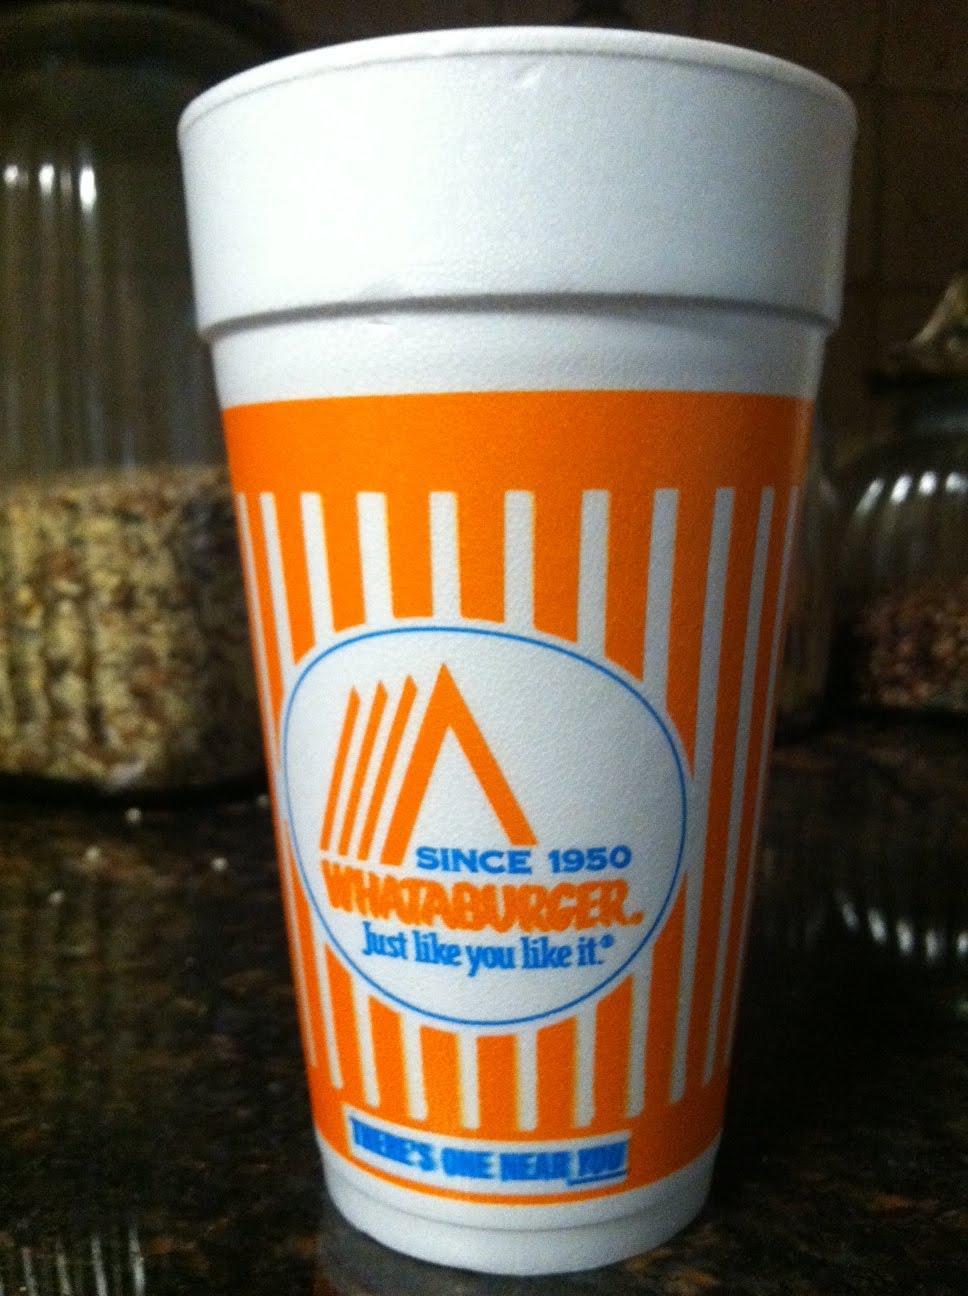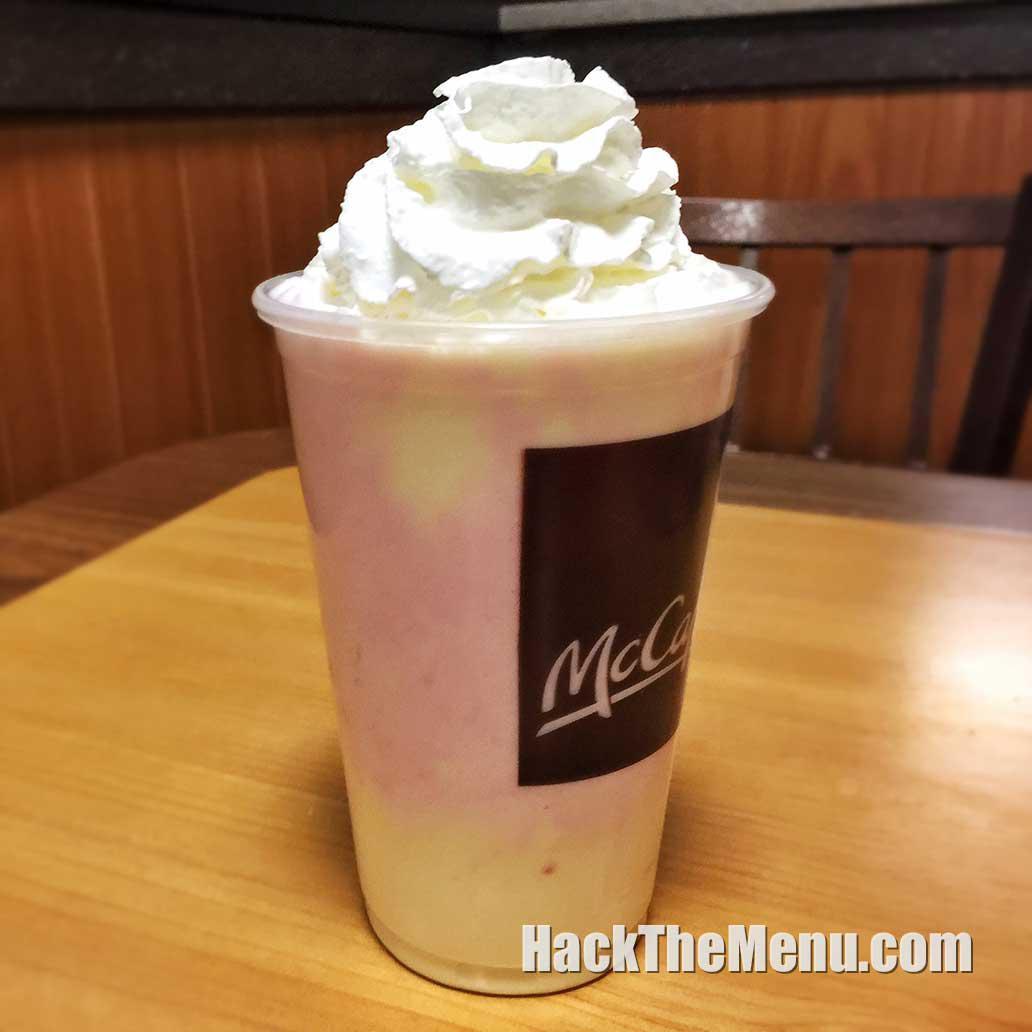The first image is the image on the left, the second image is the image on the right. Analyze the images presented: Is the assertion "The right image shows a """"Whataburger"""" cup sitting on a surface." valid? Answer yes or no. No. The first image is the image on the left, the second image is the image on the right. Analyze the images presented: Is the assertion "There are two large orange and white cups sitting directly on a table." valid? Answer yes or no. No. 